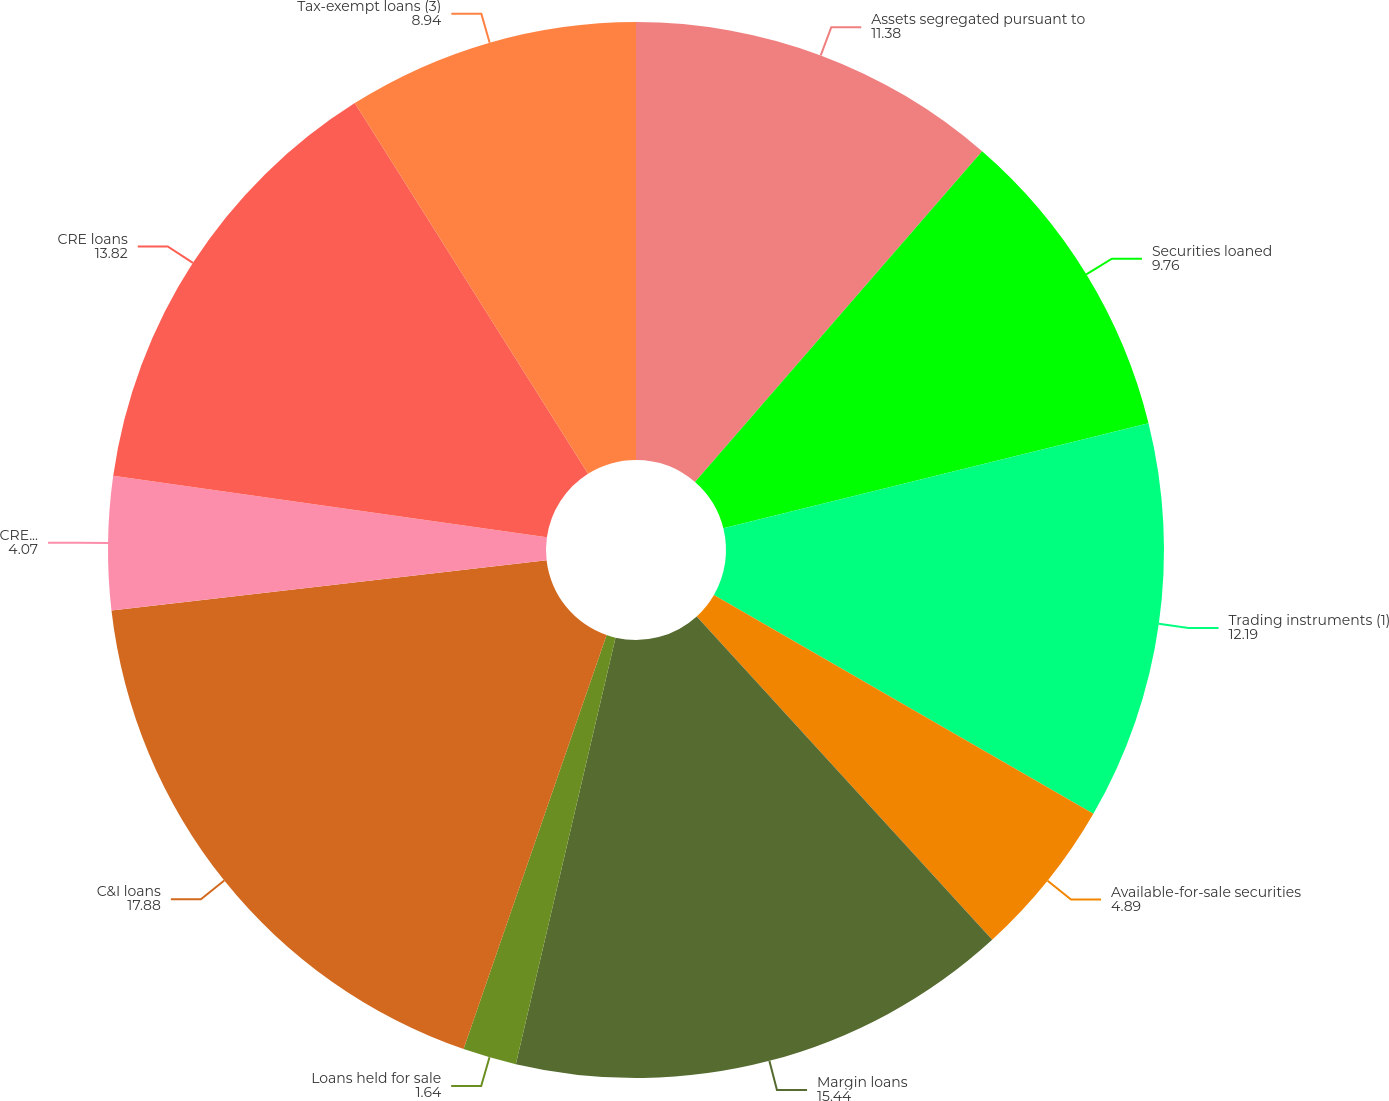Convert chart to OTSL. <chart><loc_0><loc_0><loc_500><loc_500><pie_chart><fcel>Assets segregated pursuant to<fcel>Securities loaned<fcel>Trading instruments (1)<fcel>Available-for-sale securities<fcel>Margin loans<fcel>Loans held for sale<fcel>C&I loans<fcel>CRE construction loans<fcel>CRE loans<fcel>Tax-exempt loans (3)<nl><fcel>11.38%<fcel>9.76%<fcel>12.19%<fcel>4.89%<fcel>15.44%<fcel>1.64%<fcel>17.88%<fcel>4.07%<fcel>13.82%<fcel>8.94%<nl></chart> 